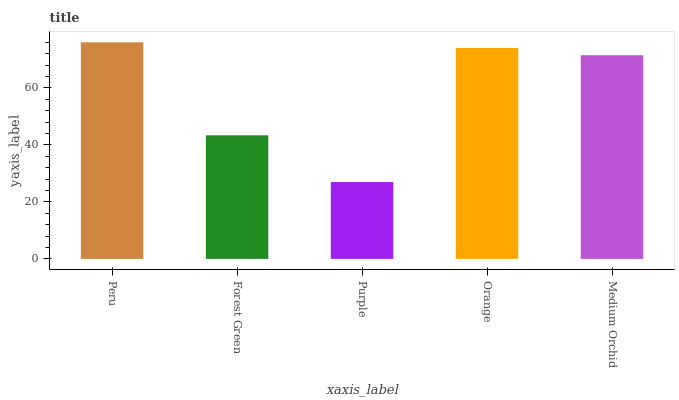Is Purple the minimum?
Answer yes or no. Yes. Is Peru the maximum?
Answer yes or no. Yes. Is Forest Green the minimum?
Answer yes or no. No. Is Forest Green the maximum?
Answer yes or no. No. Is Peru greater than Forest Green?
Answer yes or no. Yes. Is Forest Green less than Peru?
Answer yes or no. Yes. Is Forest Green greater than Peru?
Answer yes or no. No. Is Peru less than Forest Green?
Answer yes or no. No. Is Medium Orchid the high median?
Answer yes or no. Yes. Is Medium Orchid the low median?
Answer yes or no. Yes. Is Forest Green the high median?
Answer yes or no. No. Is Peru the low median?
Answer yes or no. No. 